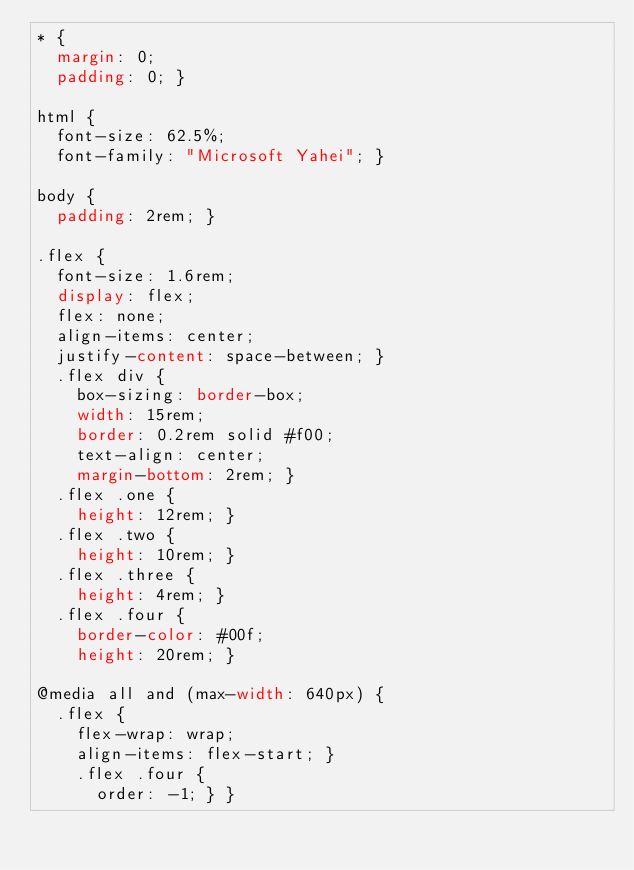<code> <loc_0><loc_0><loc_500><loc_500><_CSS_>* {
  margin: 0;
  padding: 0; }

html {
  font-size: 62.5%;
  font-family: "Microsoft Yahei"; }

body {
  padding: 2rem; }

.flex {
  font-size: 1.6rem;
  display: flex;
  flex: none;
  align-items: center;
  justify-content: space-between; }
  .flex div {
    box-sizing: border-box;
    width: 15rem;
    border: 0.2rem solid #f00;
    text-align: center;
    margin-bottom: 2rem; }
  .flex .one {
    height: 12rem; }
  .flex .two {
    height: 10rem; }
  .flex .three {
    height: 4rem; }
  .flex .four {
    border-color: #00f;
    height: 20rem; }

@media all and (max-width: 640px) {
  .flex {
    flex-wrap: wrap;
    align-items: flex-start; }
    .flex .four {
      order: -1; } }
</code> 